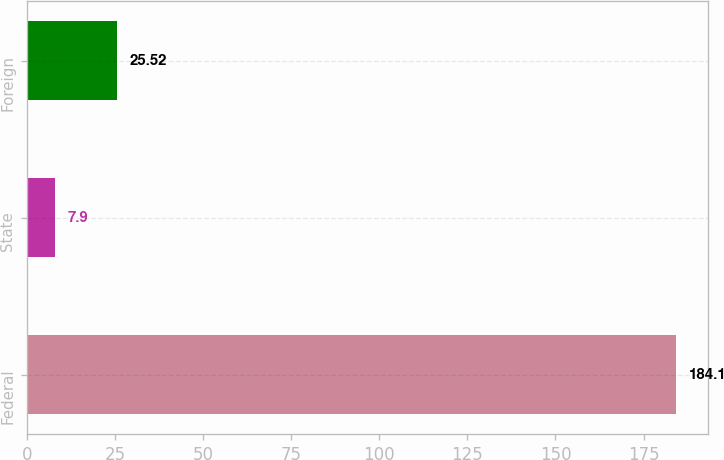<chart> <loc_0><loc_0><loc_500><loc_500><bar_chart><fcel>Federal<fcel>State<fcel>Foreign<nl><fcel>184.1<fcel>7.9<fcel>25.52<nl></chart> 